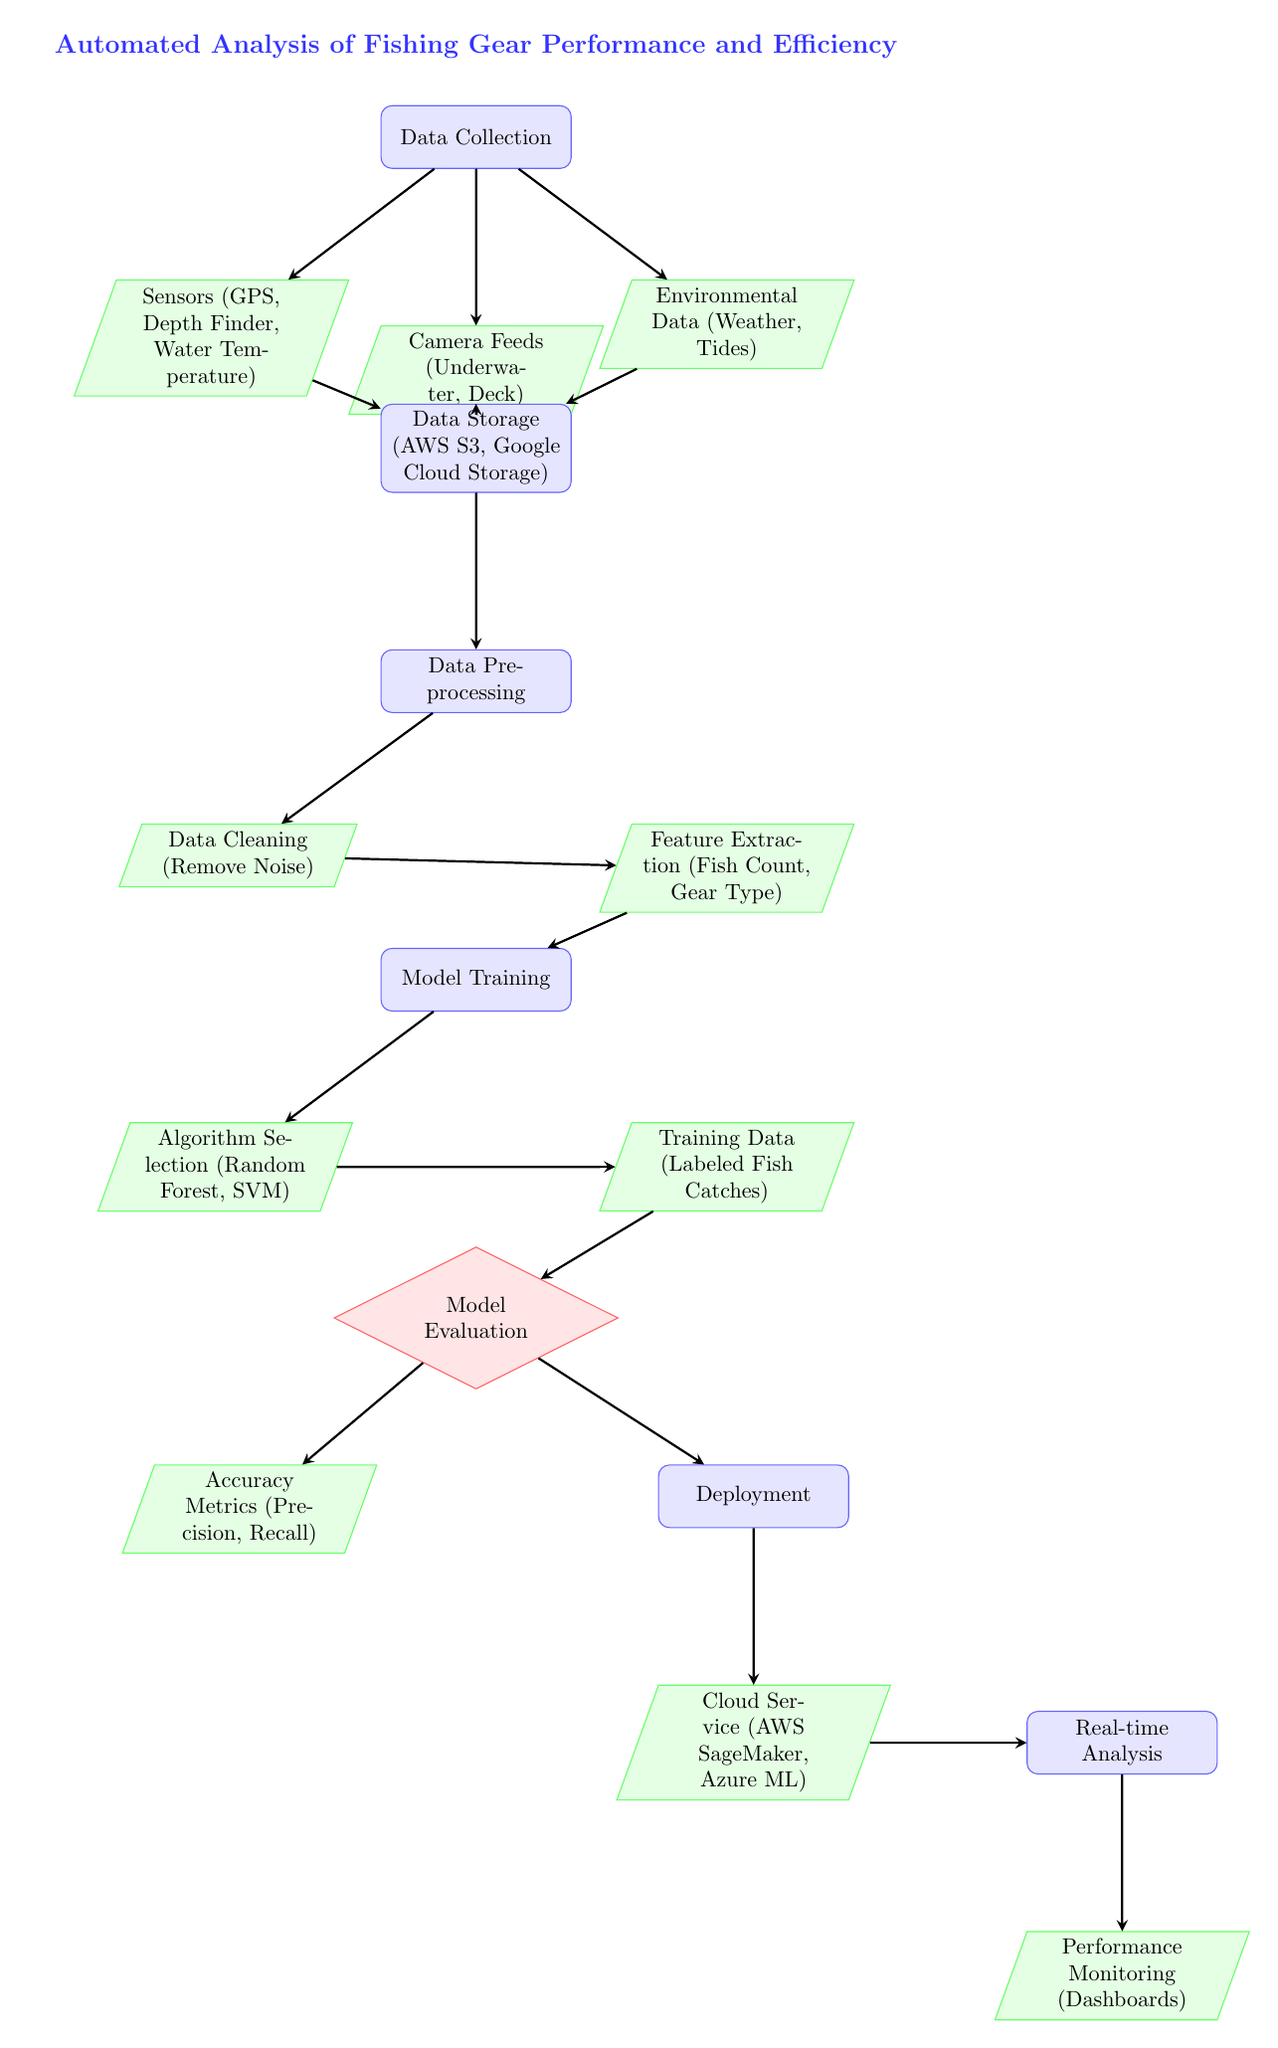What are the data sources mentioned? The diagram lists three data sources: Sensors (GPS, Depth Finder, Water Temperature), Camera Feeds (Underwater, Deck), and Environmental Data (Weather, Tides).
Answer: Sensors, Camera Feeds, Environmental Data What happens after data is stored? Following data storage, the next step in the process is Data Preprocessing, which indicates that the stored data is prepared for the model.
Answer: Data Preprocessing How many main processes are there in the diagram? The main processes in the diagram include Data Collection, Data Storage, Data Preprocessing, Model Training, Model Evaluation, Deployment, and Real-time Analysis, summing up to seven main processes.
Answer: Seven Which process directly follows Model Training? After Model Training, the next step depicted in the diagram is Model Evaluation, which assesses the performance of the trained model.
Answer: Model Evaluation What are the cloud services indicated for deployment? The diagram specifies two cloud services for deployment: AWS SageMaker and Azure ML, indicating options for implementing the model in the cloud.
Answer: AWS SageMaker, Azure ML What metrics are used in Model Evaluation? In the Model Evaluation process, the diagram references Accuracy Metrics, specifically Precision and Recall, which are common performance measures for model effectiveness.
Answer: Precision, Recall What is the purpose of Real-time Analysis? Real-time Analysis is designed for Performance Monitoring, allowing users to visualize and track the performance of the fishing gear based on the automated analysis.
Answer: Performance Monitoring What type of algorithms are selected in Model Training? During Model Training, the chosen algorithms are Random Forest and Support Vector Machine (SVM), which are both popular methods for classification tasks in machine learning.
Answer: Random Forest, SVM 